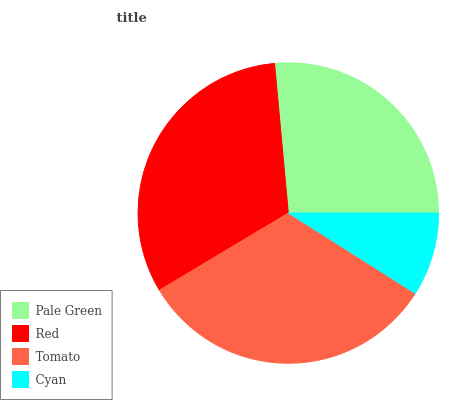Is Cyan the minimum?
Answer yes or no. Yes. Is Tomato the maximum?
Answer yes or no. Yes. Is Red the minimum?
Answer yes or no. No. Is Red the maximum?
Answer yes or no. No. Is Red greater than Pale Green?
Answer yes or no. Yes. Is Pale Green less than Red?
Answer yes or no. Yes. Is Pale Green greater than Red?
Answer yes or no. No. Is Red less than Pale Green?
Answer yes or no. No. Is Red the high median?
Answer yes or no. Yes. Is Pale Green the low median?
Answer yes or no. Yes. Is Pale Green the high median?
Answer yes or no. No. Is Tomato the low median?
Answer yes or no. No. 